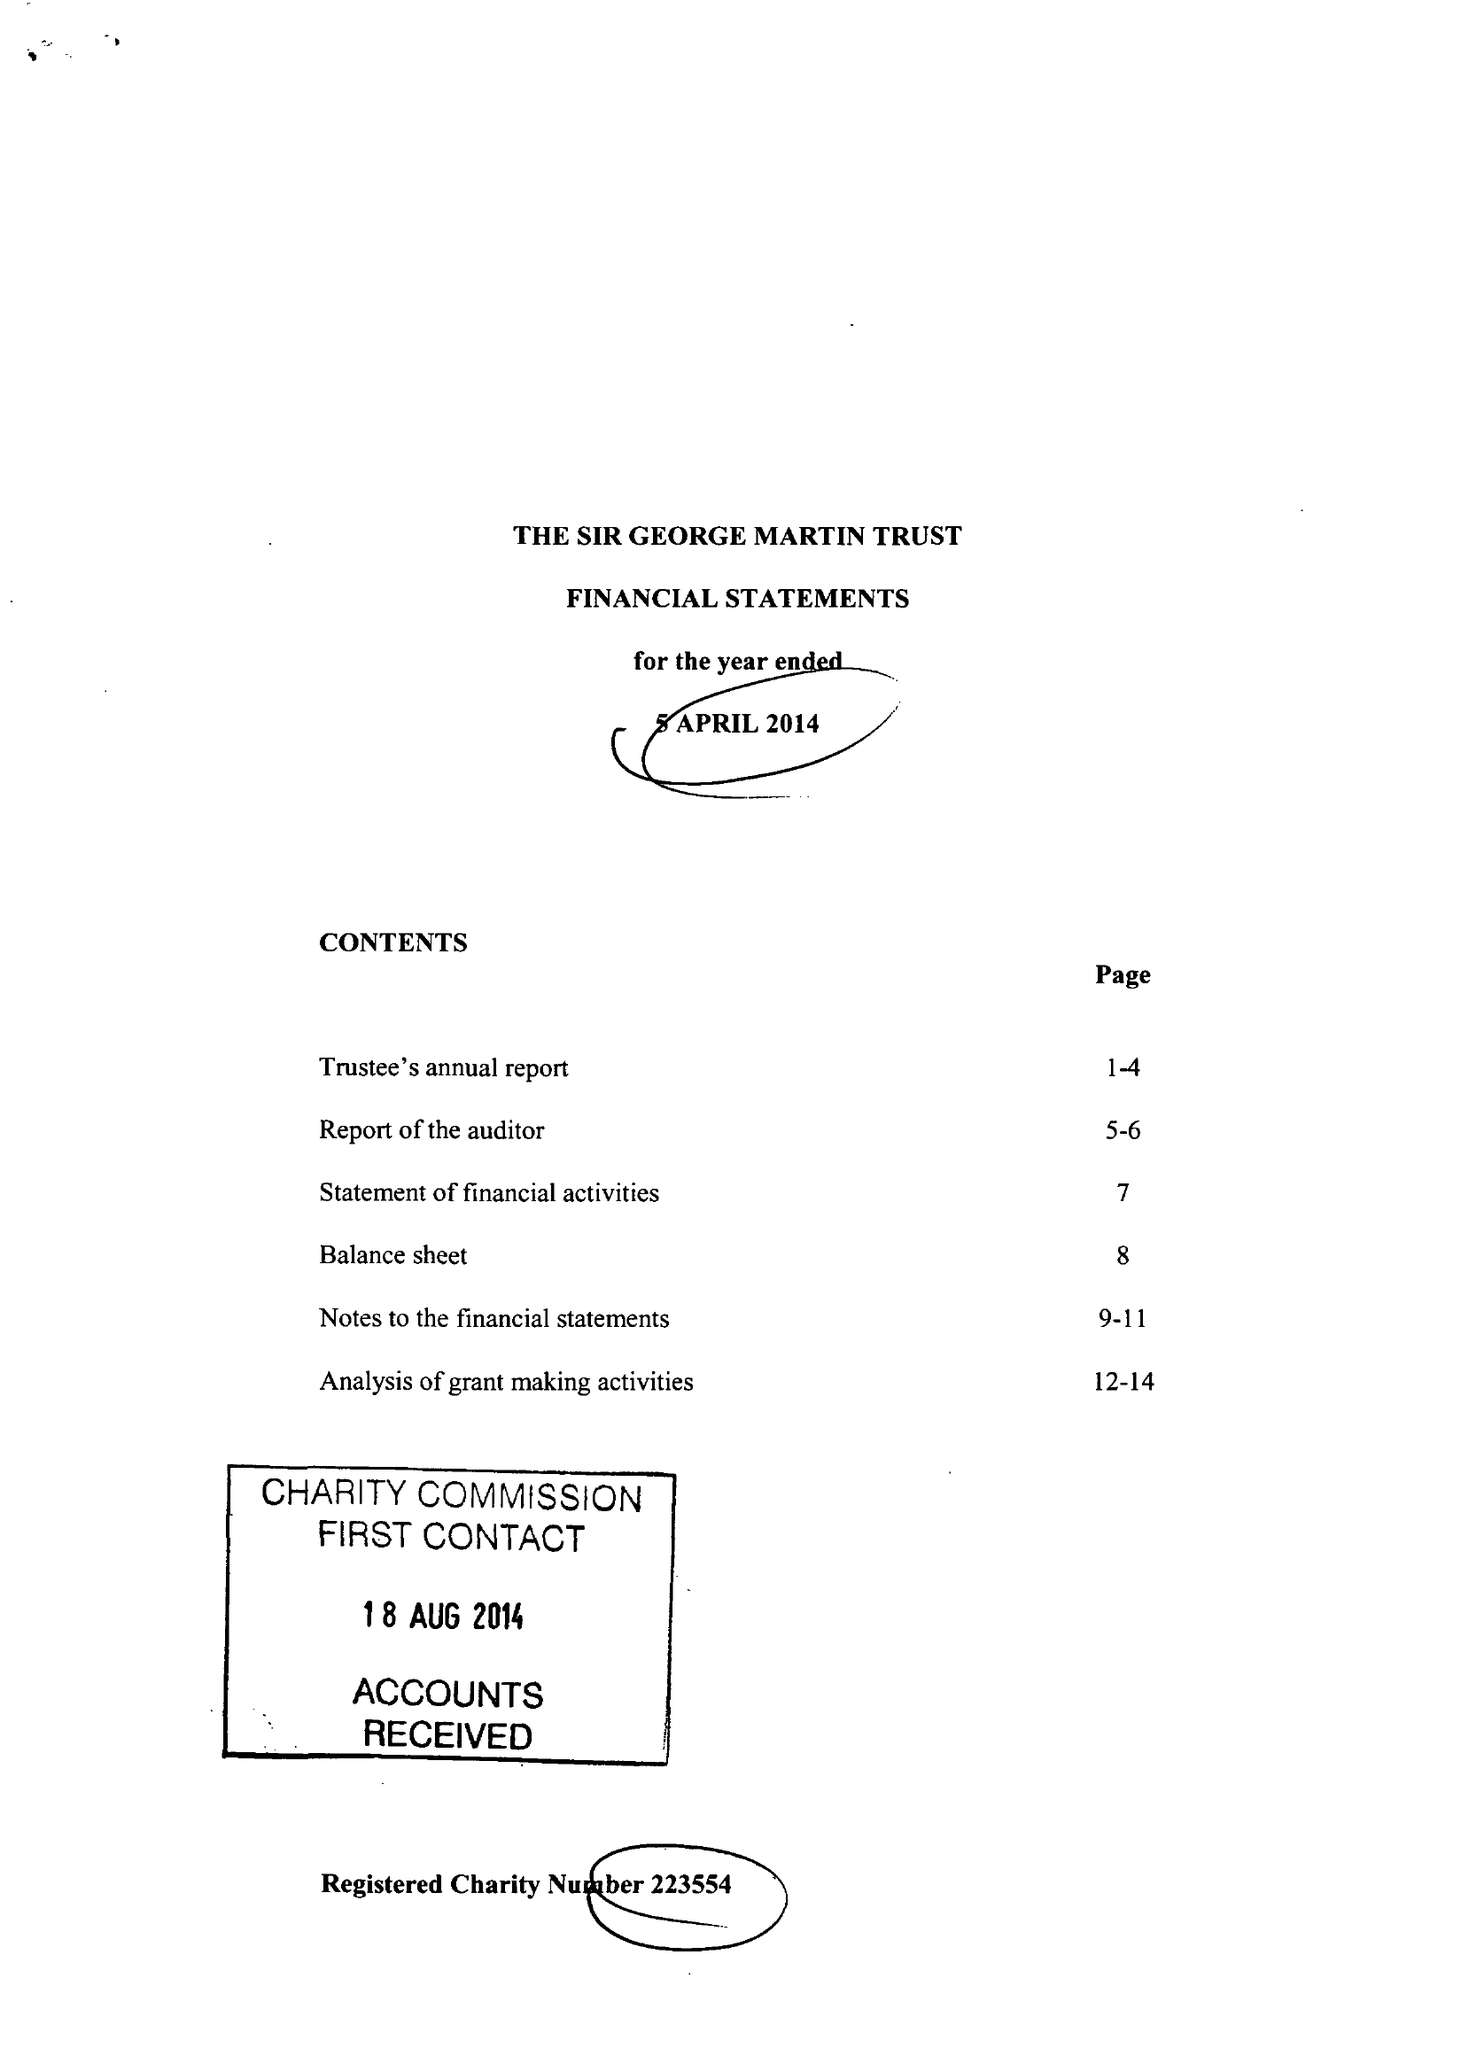What is the value for the address__street_line?
Answer the question using a single word or phrase. 6 FIRS AVENUE 